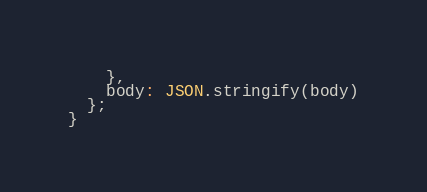Convert code to text. <code><loc_0><loc_0><loc_500><loc_500><_JavaScript_>    },
    body: JSON.stringify(body)
  };
}</code> 